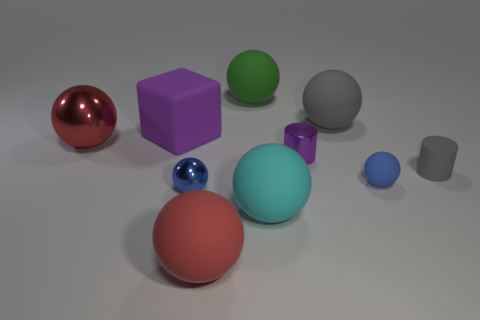What can you infer about the texture and material of the objects? The objects have a glossy finish, reflected in the way they catch the light and shine. These attributes imply they are made of a reflective material, like polished plastic or glass, enhancing the vividness of their colors. 